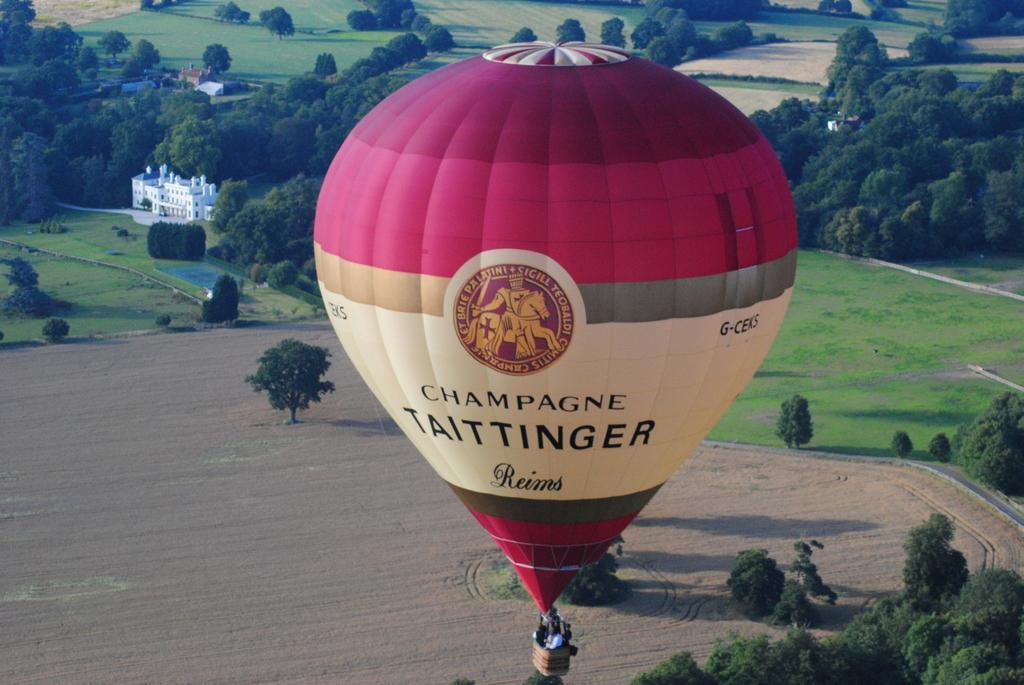How would you summarize this image in a sentence or two? In this picture I can see group of people standing in a wicker basket of the hot air balloon, and in the background there are houses and trees. 